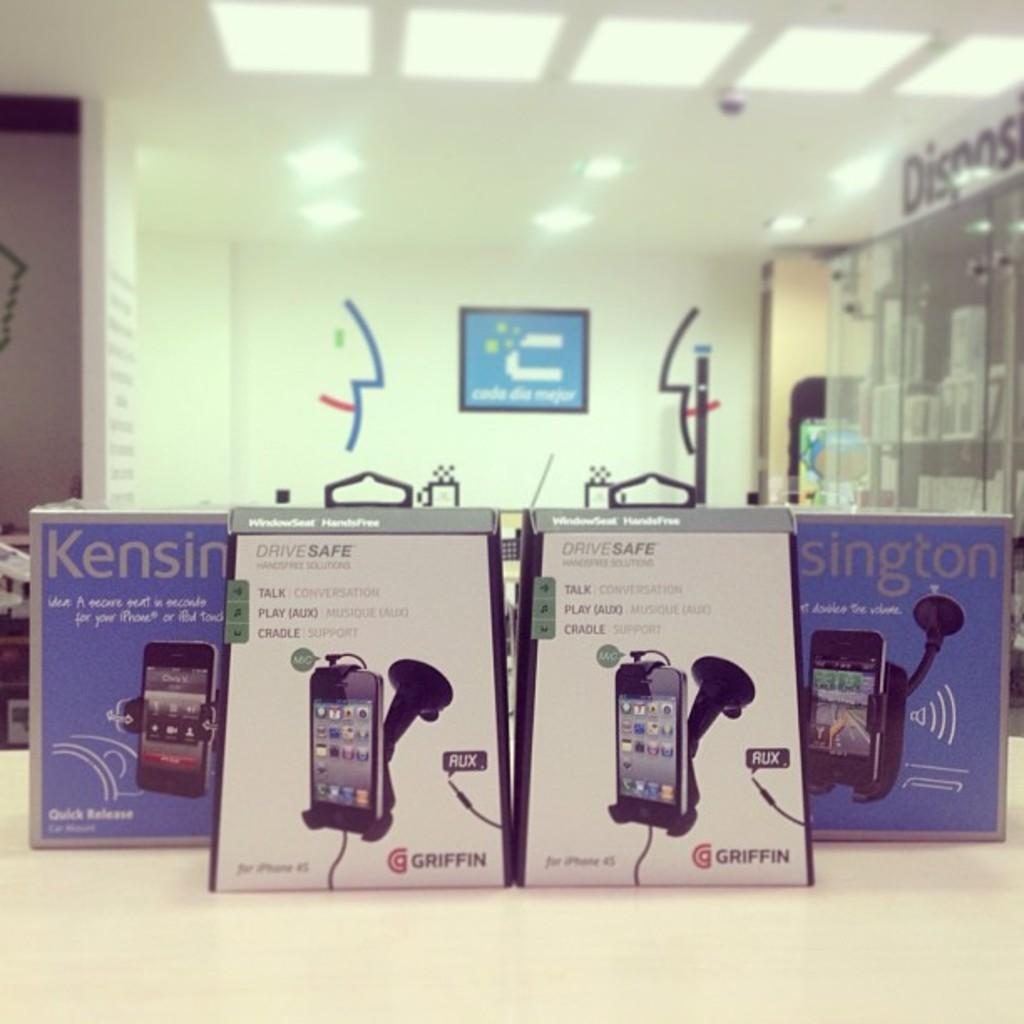Provide a one-sentence caption for the provided image. 4 boxes of Kensington smart phone holders on display. 